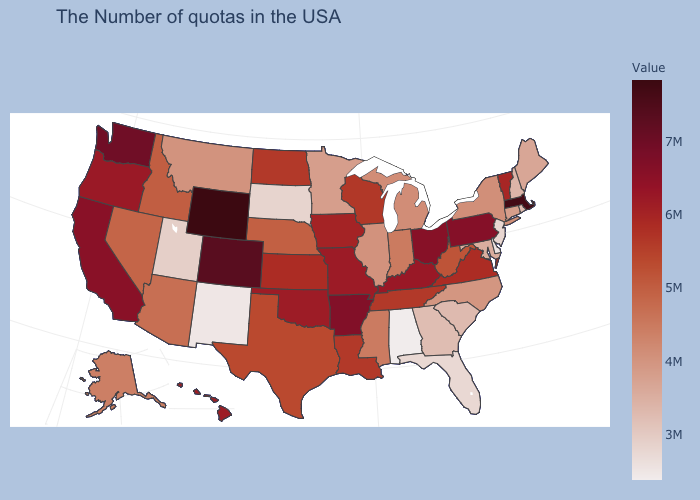Does Colorado have a higher value than Utah?
Answer briefly. Yes. Among the states that border Nevada , does Utah have the lowest value?
Answer briefly. Yes. Which states have the lowest value in the MidWest?
Keep it brief. South Dakota. 